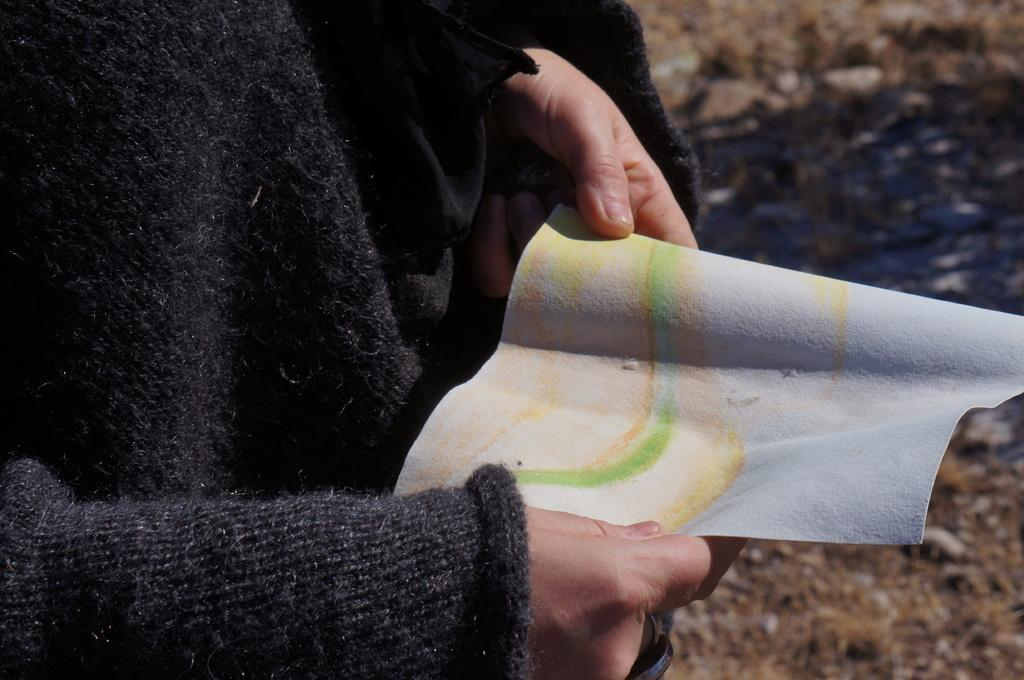What is the person in the image doing? The person's hands are holding a paper. Can you describe the person's surroundings? There is dried grass on the ground in the background of the image. What type of meal is the person eating in the image? There is no meal present in the image; the person is holding a paper. What color are the person's eyes in the image? The image does not provide information about the person's eye color. 